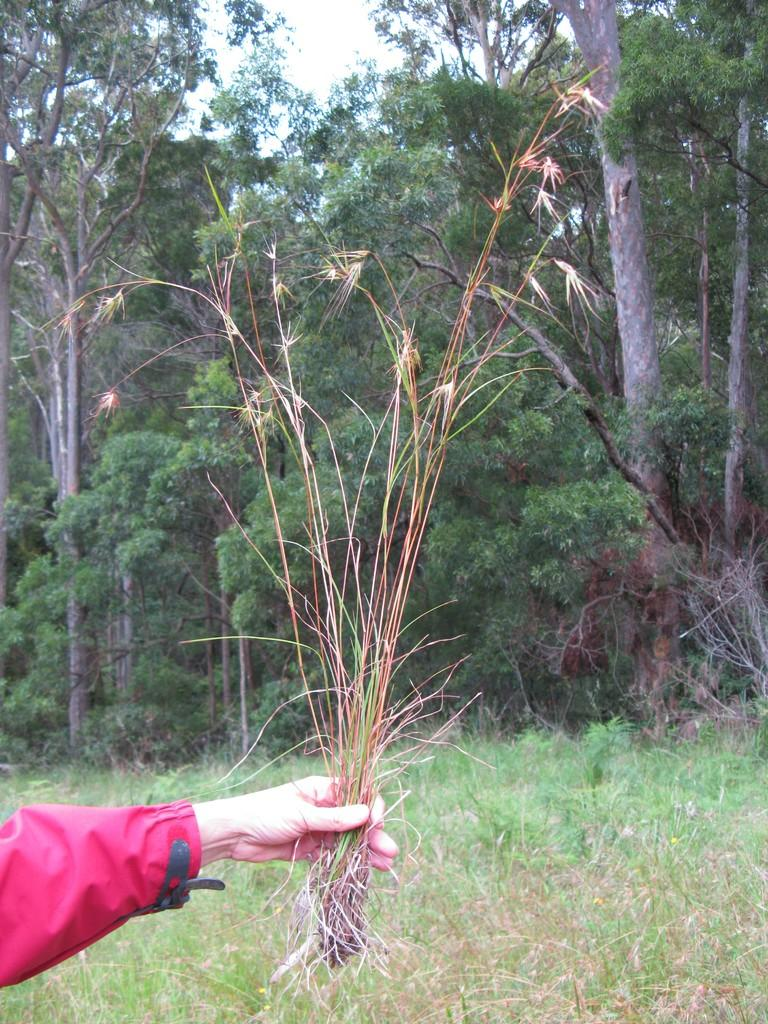What are the people in the image holding? The people in the image are holding grass. What can be seen in the background of the image? There are trees and grass visible in the background of the image. What else is visible in the background of the image? The sky is visible in the background of the image. What type of bun is being used to hold the grass in the image? There is no bun present in the image; the people are holding the grass directly. 